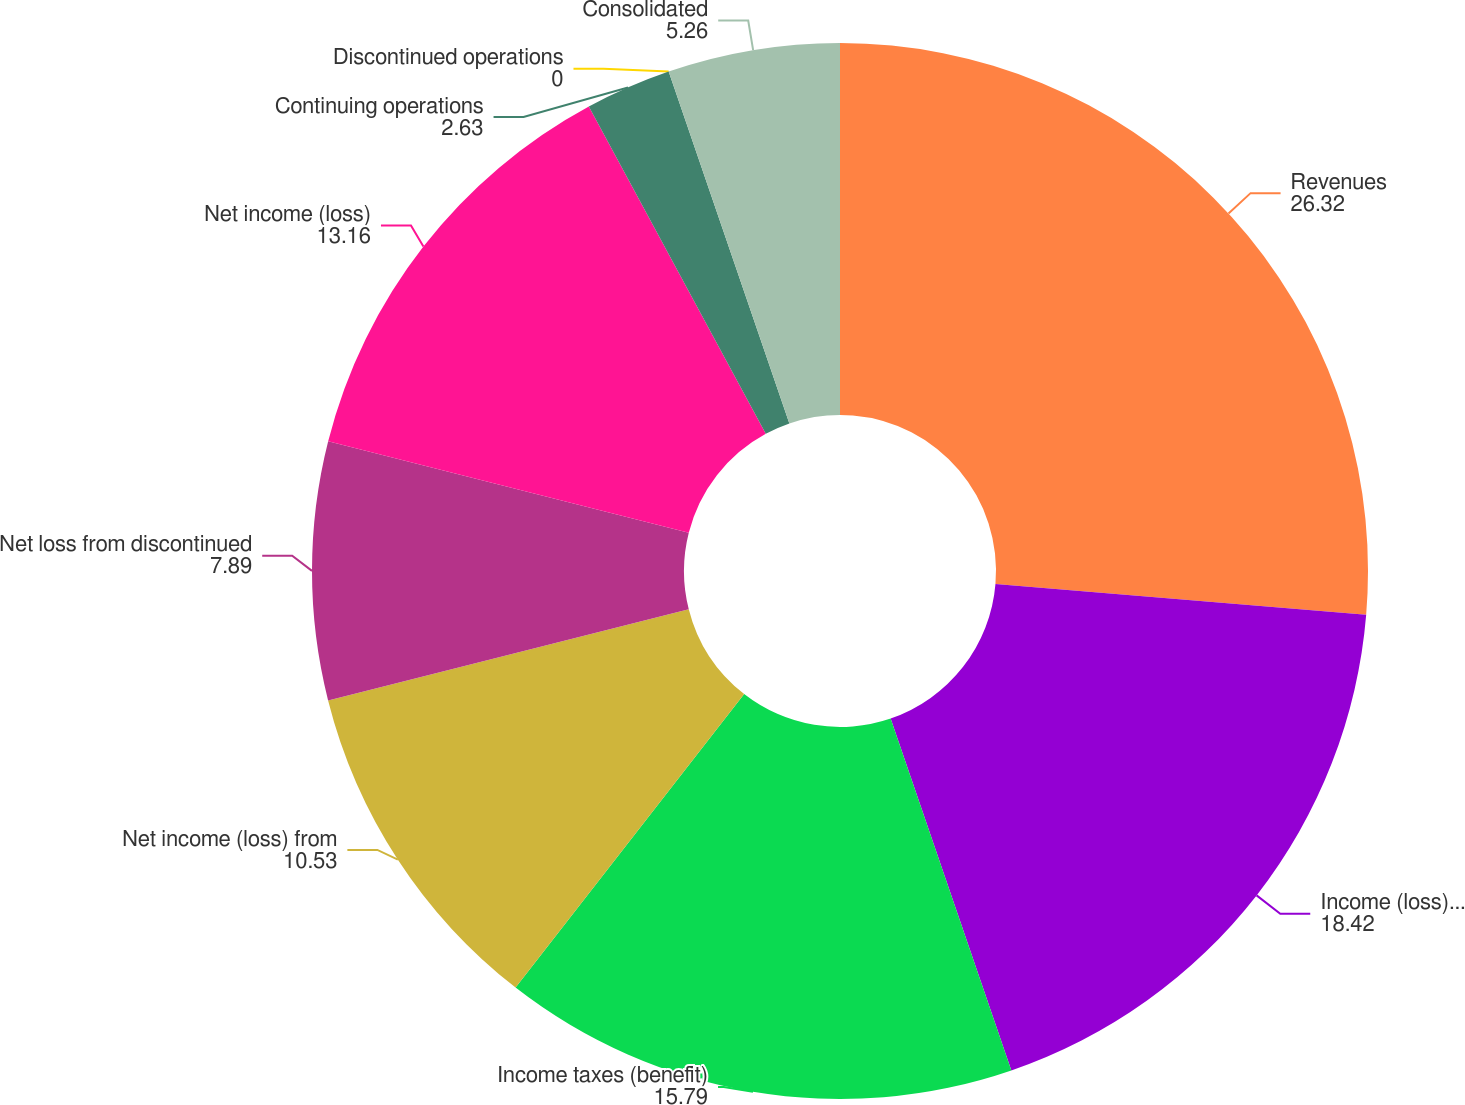<chart> <loc_0><loc_0><loc_500><loc_500><pie_chart><fcel>Revenues<fcel>Income (loss) from continuing<fcel>Income taxes (benefit)<fcel>Net income (loss) from<fcel>Net loss from discontinued<fcel>Net income (loss)<fcel>Continuing operations<fcel>Discontinued operations<fcel>Consolidated<nl><fcel>26.32%<fcel>18.42%<fcel>15.79%<fcel>10.53%<fcel>7.89%<fcel>13.16%<fcel>2.63%<fcel>0.0%<fcel>5.26%<nl></chart> 